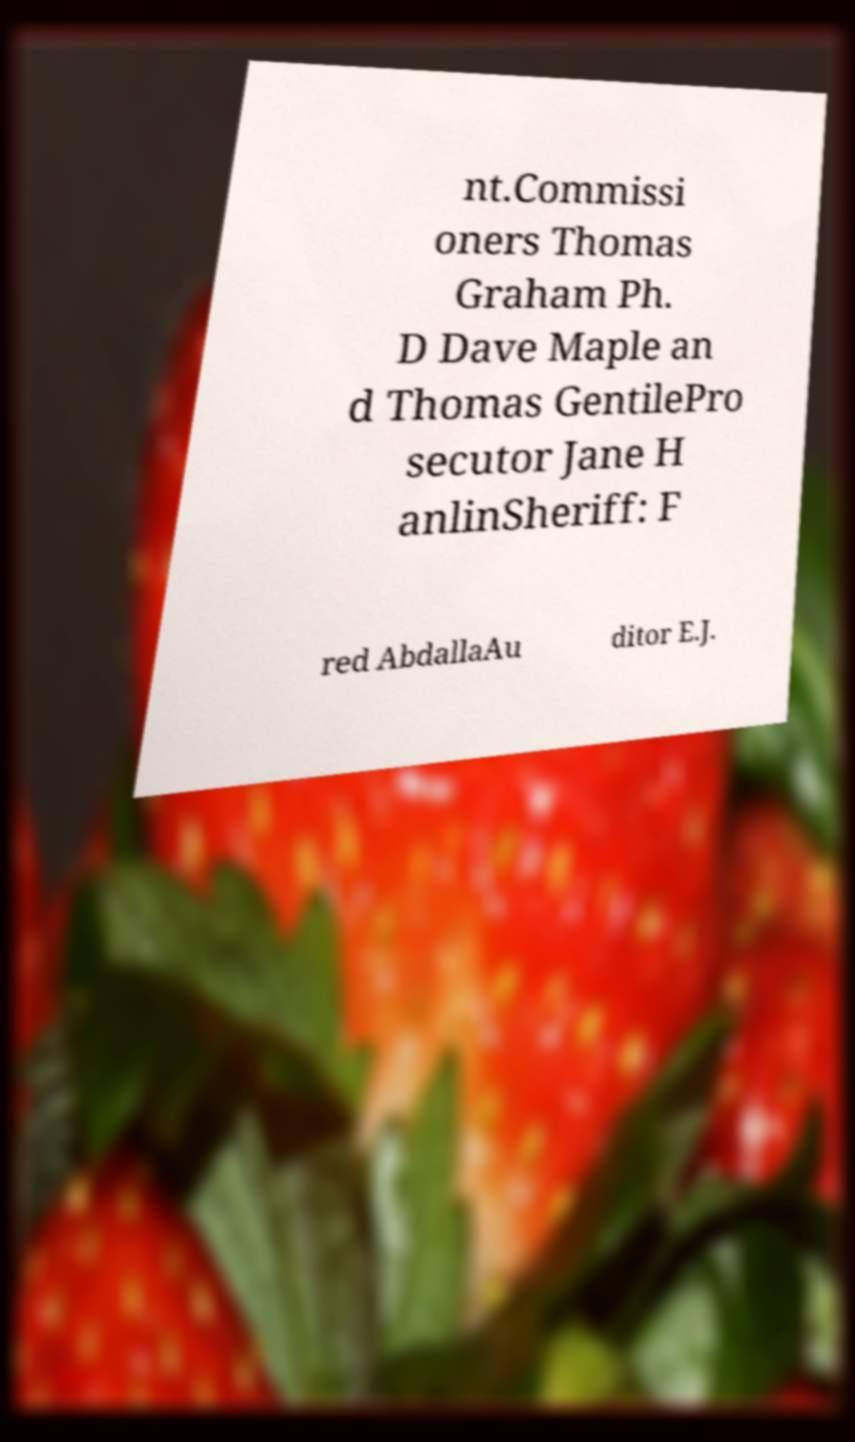Can you read and provide the text displayed in the image?This photo seems to have some interesting text. Can you extract and type it out for me? nt.Commissi oners Thomas Graham Ph. D Dave Maple an d Thomas GentilePro secutor Jane H anlinSheriff: F red AbdallaAu ditor E.J. 